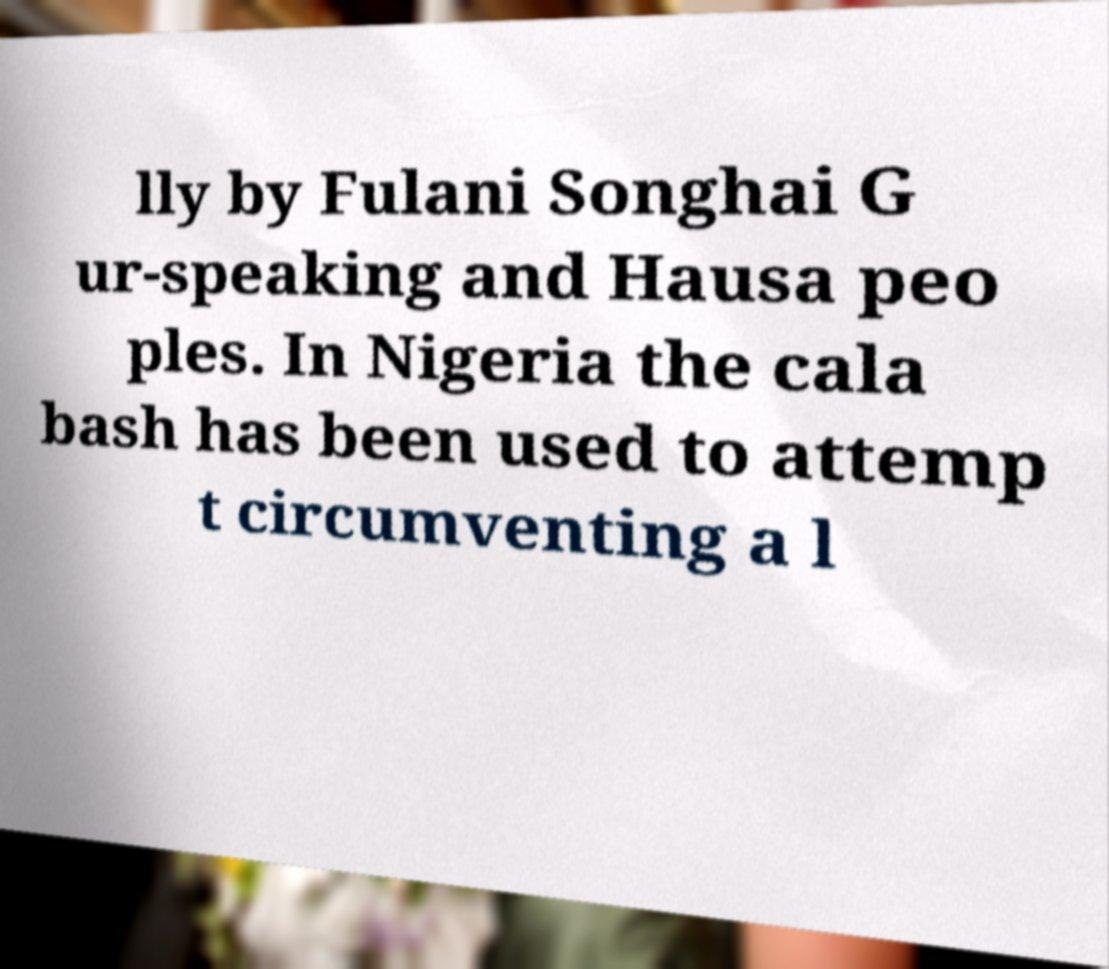There's text embedded in this image that I need extracted. Can you transcribe it verbatim? lly by Fulani Songhai G ur-speaking and Hausa peo ples. In Nigeria the cala bash has been used to attemp t circumventing a l 